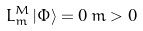<formula> <loc_0><loc_0><loc_500><loc_500>L _ { m } ^ { M } \, | \Phi \rangle = 0 \, m > 0</formula> 